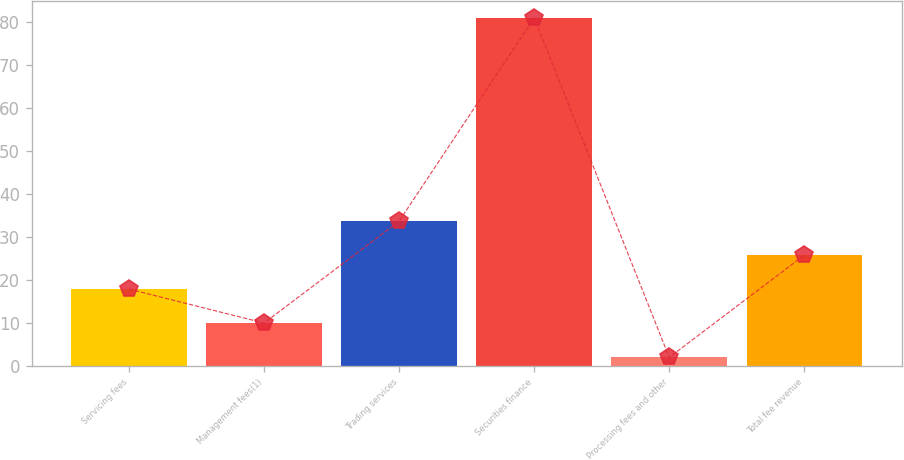Convert chart. <chart><loc_0><loc_0><loc_500><loc_500><bar_chart><fcel>Servicing fees<fcel>Management fees(1)<fcel>Trading services<fcel>Securities finance<fcel>Processing fees and other<fcel>Total fee revenue<nl><fcel>17.9<fcel>10<fcel>33.7<fcel>81<fcel>2<fcel>25.8<nl></chart> 